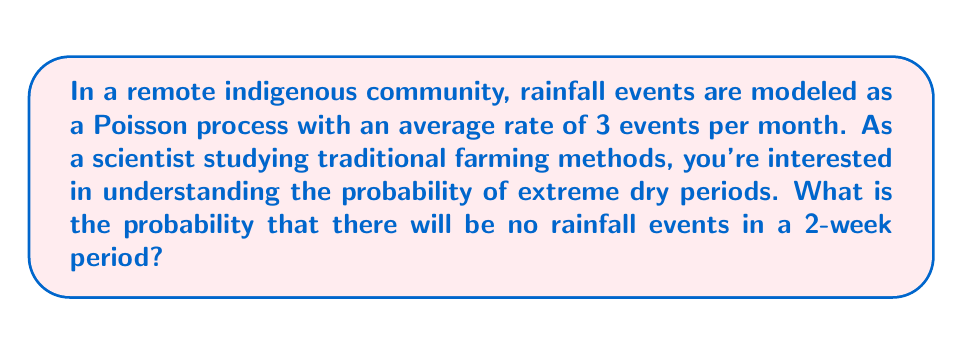Help me with this question. Let's approach this step-by-step:

1) First, we need to adjust the rate for a 2-week period. If there are 3 events per month on average, then in 2 weeks (half a month), the average rate would be:

   $\lambda = 3 \times \frac{1}{2} = 1.5$ events per 2 weeks

2) In a Poisson process, the probability of exactly $k$ events occurring in a time interval is given by the Poisson probability mass function:

   $$P(X = k) = \frac{e^{-\lambda}\lambda^k}{k!}$$

   where $\lambda$ is the average number of events in the interval.

3) We want the probability of zero events $(k = 0)$ in a 2-week period. Substituting into the formula:

   $$P(X = 0) = \frac{e^{-1.5}(1.5)^0}{0!} = e^{-1.5}$$

4) Calculate this value:

   $e^{-1.5} \approx 0.2231$

Therefore, the probability of no rainfall events in a 2-week period is approximately 0.2231 or 22.31%.
Answer: 0.2231 